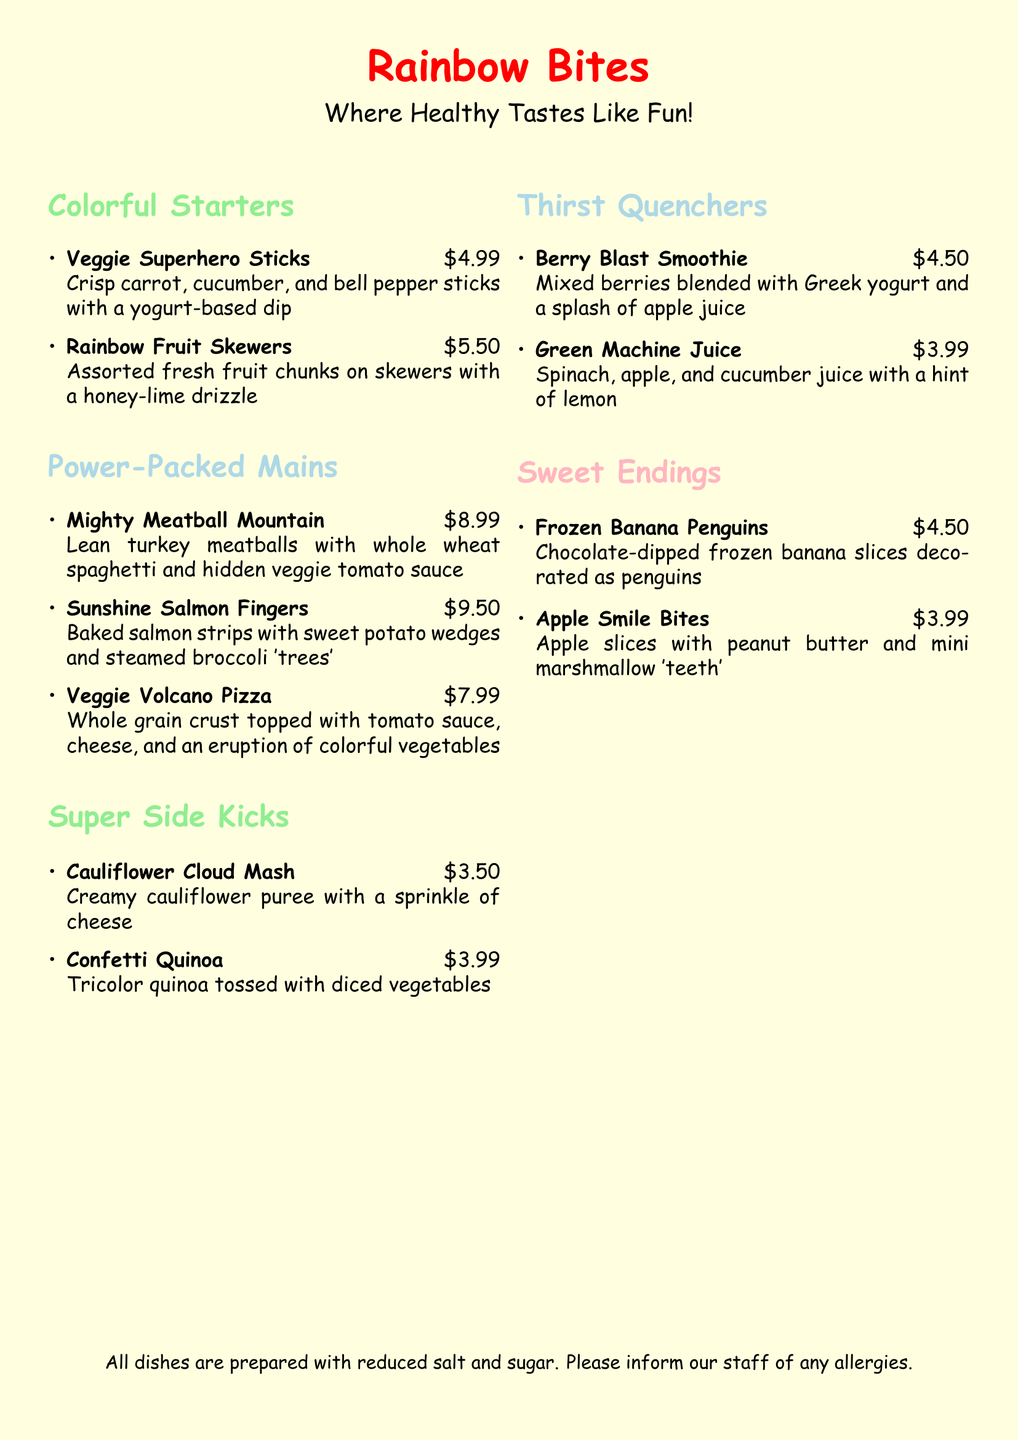What is the name of the restaurant? The name of the restaurant is prominently displayed at the top of the menu.
Answer: Rainbow Bites What is the price of Rainbow Fruit Skewers? The price can be found next to the dish description.
Answer: $5.50 What color is associated with Starters? Each section of the menu is color-coded for visual appeal.
Answer: Light green How many Power-Packed Mains are listed? The number of items can be counted in the "Power-Packed Mains" section.
Answer: Three What is the main ingredient in Sunshine Salmon Fingers? The dish description often highlights key ingredients.
Answer: Salmon What are the Sweet Endings made with? The sweet dishes are described next to their names and include key ingredients.
Answer: Fruits and chocolate Which drink contains spinach? The ingredient list helps identify drinks based on their components.
Answer: Green Machine Juice What type of crust is used for the Veggie Volcano Pizza? The dish description provides details about the crust used.
Answer: Whole grain What is a unique feature of Apple Smile Bites? The description details how the dish is presented amusingly for kids.
Answer: Mini marshmallow 'teeth' 